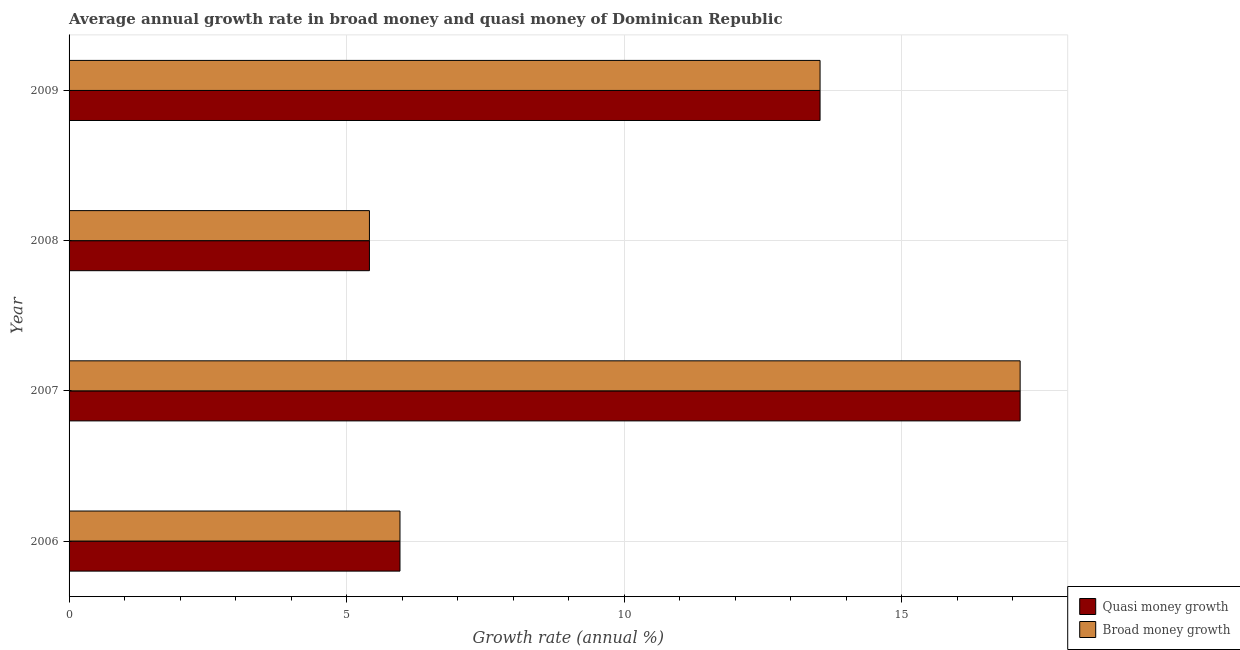How many groups of bars are there?
Ensure brevity in your answer.  4. Are the number of bars on each tick of the Y-axis equal?
Your answer should be compact. Yes. What is the label of the 3rd group of bars from the top?
Ensure brevity in your answer.  2007. What is the annual growth rate in quasi money in 2006?
Your response must be concise. 5.96. Across all years, what is the maximum annual growth rate in broad money?
Give a very brief answer. 17.14. Across all years, what is the minimum annual growth rate in broad money?
Your answer should be compact. 5.41. What is the total annual growth rate in broad money in the graph?
Provide a succinct answer. 42.04. What is the difference between the annual growth rate in quasi money in 2006 and that in 2007?
Offer a very short reply. -11.17. What is the difference between the annual growth rate in quasi money in 2009 and the annual growth rate in broad money in 2007?
Provide a short and direct response. -3.61. What is the average annual growth rate in broad money per year?
Offer a very short reply. 10.51. In the year 2007, what is the difference between the annual growth rate in broad money and annual growth rate in quasi money?
Offer a very short reply. 0. In how many years, is the annual growth rate in quasi money greater than 9 %?
Make the answer very short. 2. What is the ratio of the annual growth rate in broad money in 2006 to that in 2008?
Ensure brevity in your answer.  1.1. Is the difference between the annual growth rate in quasi money in 2007 and 2008 greater than the difference between the annual growth rate in broad money in 2007 and 2008?
Provide a succinct answer. No. What is the difference between the highest and the second highest annual growth rate in broad money?
Offer a terse response. 3.6. What is the difference between the highest and the lowest annual growth rate in quasi money?
Your response must be concise. 11.72. What does the 1st bar from the top in 2008 represents?
Make the answer very short. Broad money growth. What does the 1st bar from the bottom in 2008 represents?
Keep it short and to the point. Quasi money growth. Are all the bars in the graph horizontal?
Offer a terse response. Yes. Does the graph contain any zero values?
Your response must be concise. No. Does the graph contain grids?
Your answer should be compact. Yes. Where does the legend appear in the graph?
Offer a very short reply. Bottom right. What is the title of the graph?
Keep it short and to the point. Average annual growth rate in broad money and quasi money of Dominican Republic. What is the label or title of the X-axis?
Your answer should be very brief. Growth rate (annual %). What is the Growth rate (annual %) of Quasi money growth in 2006?
Offer a terse response. 5.96. What is the Growth rate (annual %) of Broad money growth in 2006?
Provide a short and direct response. 5.96. What is the Growth rate (annual %) in Quasi money growth in 2007?
Offer a terse response. 17.14. What is the Growth rate (annual %) in Broad money growth in 2007?
Your answer should be compact. 17.14. What is the Growth rate (annual %) in Quasi money growth in 2008?
Make the answer very short. 5.41. What is the Growth rate (annual %) of Broad money growth in 2008?
Your response must be concise. 5.41. What is the Growth rate (annual %) of Quasi money growth in 2009?
Offer a terse response. 13.53. What is the Growth rate (annual %) of Broad money growth in 2009?
Provide a succinct answer. 13.53. Across all years, what is the maximum Growth rate (annual %) in Quasi money growth?
Make the answer very short. 17.14. Across all years, what is the maximum Growth rate (annual %) of Broad money growth?
Your response must be concise. 17.14. Across all years, what is the minimum Growth rate (annual %) in Quasi money growth?
Provide a succinct answer. 5.41. Across all years, what is the minimum Growth rate (annual %) of Broad money growth?
Offer a very short reply. 5.41. What is the total Growth rate (annual %) in Quasi money growth in the graph?
Offer a very short reply. 42.04. What is the total Growth rate (annual %) of Broad money growth in the graph?
Make the answer very short. 42.04. What is the difference between the Growth rate (annual %) of Quasi money growth in 2006 and that in 2007?
Make the answer very short. -11.17. What is the difference between the Growth rate (annual %) of Broad money growth in 2006 and that in 2007?
Provide a succinct answer. -11.17. What is the difference between the Growth rate (annual %) in Quasi money growth in 2006 and that in 2008?
Your answer should be compact. 0.55. What is the difference between the Growth rate (annual %) of Broad money growth in 2006 and that in 2008?
Ensure brevity in your answer.  0.55. What is the difference between the Growth rate (annual %) in Quasi money growth in 2006 and that in 2009?
Keep it short and to the point. -7.57. What is the difference between the Growth rate (annual %) of Broad money growth in 2006 and that in 2009?
Keep it short and to the point. -7.57. What is the difference between the Growth rate (annual %) of Quasi money growth in 2007 and that in 2008?
Your answer should be very brief. 11.72. What is the difference between the Growth rate (annual %) of Broad money growth in 2007 and that in 2008?
Your answer should be very brief. 11.72. What is the difference between the Growth rate (annual %) in Quasi money growth in 2007 and that in 2009?
Offer a very short reply. 3.61. What is the difference between the Growth rate (annual %) of Broad money growth in 2007 and that in 2009?
Keep it short and to the point. 3.61. What is the difference between the Growth rate (annual %) of Quasi money growth in 2008 and that in 2009?
Make the answer very short. -8.12. What is the difference between the Growth rate (annual %) in Broad money growth in 2008 and that in 2009?
Make the answer very short. -8.12. What is the difference between the Growth rate (annual %) in Quasi money growth in 2006 and the Growth rate (annual %) in Broad money growth in 2007?
Offer a very short reply. -11.17. What is the difference between the Growth rate (annual %) of Quasi money growth in 2006 and the Growth rate (annual %) of Broad money growth in 2008?
Give a very brief answer. 0.55. What is the difference between the Growth rate (annual %) in Quasi money growth in 2006 and the Growth rate (annual %) in Broad money growth in 2009?
Offer a very short reply. -7.57. What is the difference between the Growth rate (annual %) of Quasi money growth in 2007 and the Growth rate (annual %) of Broad money growth in 2008?
Give a very brief answer. 11.72. What is the difference between the Growth rate (annual %) of Quasi money growth in 2007 and the Growth rate (annual %) of Broad money growth in 2009?
Provide a short and direct response. 3.61. What is the difference between the Growth rate (annual %) in Quasi money growth in 2008 and the Growth rate (annual %) in Broad money growth in 2009?
Keep it short and to the point. -8.12. What is the average Growth rate (annual %) of Quasi money growth per year?
Give a very brief answer. 10.51. What is the average Growth rate (annual %) of Broad money growth per year?
Keep it short and to the point. 10.51. In the year 2006, what is the difference between the Growth rate (annual %) of Quasi money growth and Growth rate (annual %) of Broad money growth?
Provide a short and direct response. 0. In the year 2009, what is the difference between the Growth rate (annual %) of Quasi money growth and Growth rate (annual %) of Broad money growth?
Your answer should be compact. 0. What is the ratio of the Growth rate (annual %) of Quasi money growth in 2006 to that in 2007?
Give a very brief answer. 0.35. What is the ratio of the Growth rate (annual %) of Broad money growth in 2006 to that in 2007?
Offer a very short reply. 0.35. What is the ratio of the Growth rate (annual %) of Quasi money growth in 2006 to that in 2008?
Give a very brief answer. 1.1. What is the ratio of the Growth rate (annual %) of Broad money growth in 2006 to that in 2008?
Your response must be concise. 1.1. What is the ratio of the Growth rate (annual %) in Quasi money growth in 2006 to that in 2009?
Give a very brief answer. 0.44. What is the ratio of the Growth rate (annual %) in Broad money growth in 2006 to that in 2009?
Your response must be concise. 0.44. What is the ratio of the Growth rate (annual %) in Quasi money growth in 2007 to that in 2008?
Provide a short and direct response. 3.17. What is the ratio of the Growth rate (annual %) in Broad money growth in 2007 to that in 2008?
Make the answer very short. 3.17. What is the ratio of the Growth rate (annual %) in Quasi money growth in 2007 to that in 2009?
Your answer should be compact. 1.27. What is the ratio of the Growth rate (annual %) in Broad money growth in 2007 to that in 2009?
Give a very brief answer. 1.27. What is the ratio of the Growth rate (annual %) in Broad money growth in 2008 to that in 2009?
Give a very brief answer. 0.4. What is the difference between the highest and the second highest Growth rate (annual %) in Quasi money growth?
Keep it short and to the point. 3.61. What is the difference between the highest and the second highest Growth rate (annual %) of Broad money growth?
Your answer should be compact. 3.61. What is the difference between the highest and the lowest Growth rate (annual %) in Quasi money growth?
Give a very brief answer. 11.72. What is the difference between the highest and the lowest Growth rate (annual %) in Broad money growth?
Your answer should be very brief. 11.72. 